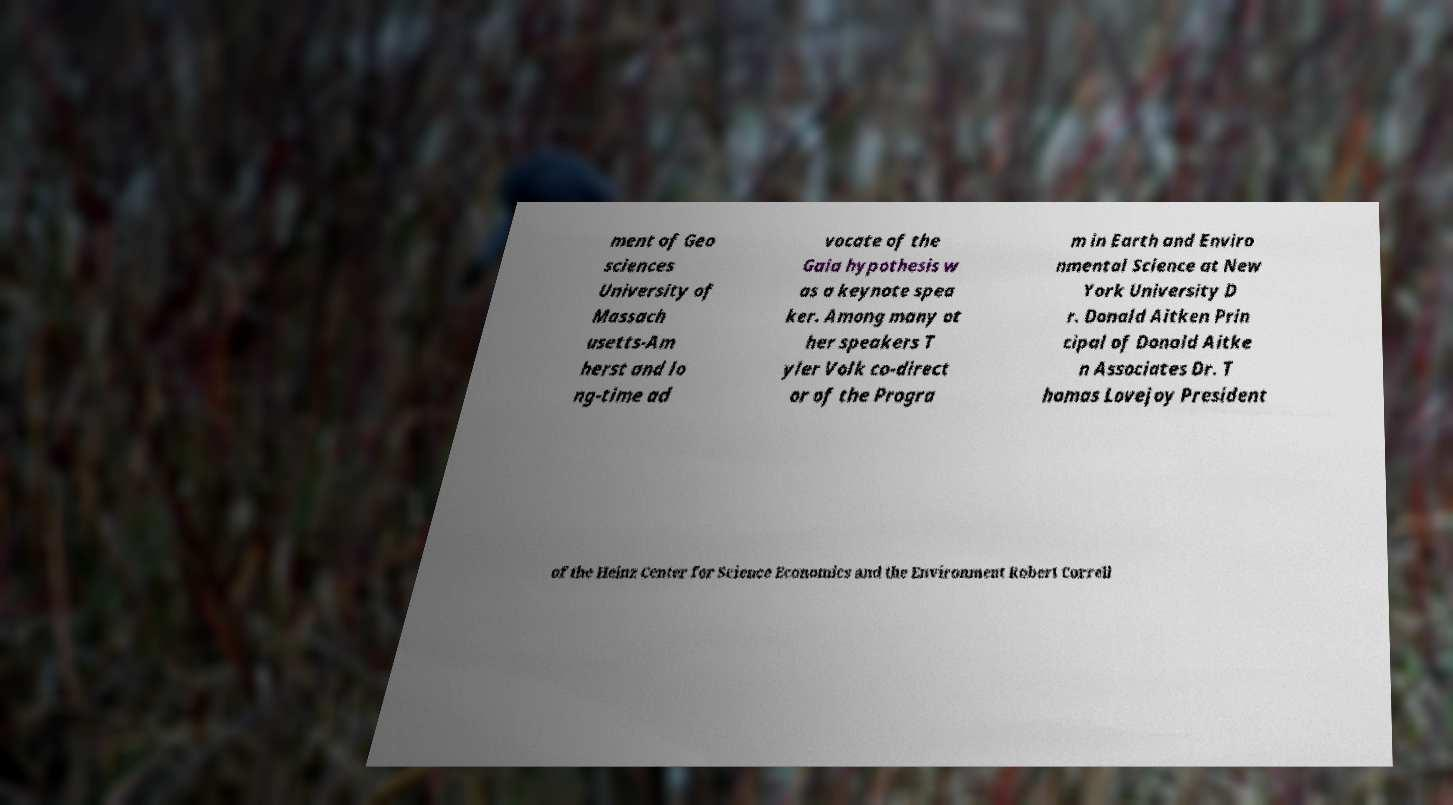There's text embedded in this image that I need extracted. Can you transcribe it verbatim? ment of Geo sciences University of Massach usetts-Am herst and lo ng-time ad vocate of the Gaia hypothesis w as a keynote spea ker. Among many ot her speakers T yler Volk co-direct or of the Progra m in Earth and Enviro nmental Science at New York University D r. Donald Aitken Prin cipal of Donald Aitke n Associates Dr. T homas Lovejoy President of the Heinz Center for Science Economics and the Environment Robert Correll 